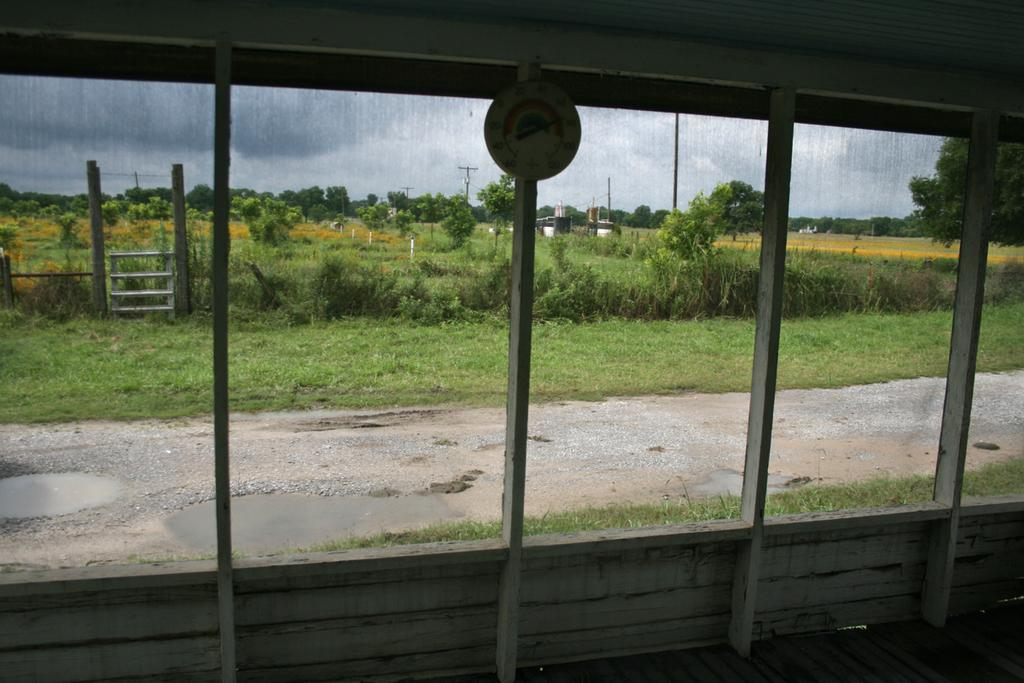What is present in the image that separates the interior and exterior spaces? There is a wall in the image. What feature of the wall allows for visibility between the interior and exterior spaces? There are glass windows in the wall. What can be seen through the glass windows? The glass windows allow for the visibility of a road, grassland, a tree, and the sky. What type of sugar is being used to fuel the fear and hate in the image? There is no mention of sugar, fear, or hate in the image; it only features a wall with glass windows. 